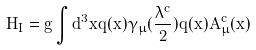Convert formula to latex. <formula><loc_0><loc_0><loc_500><loc_500>H _ { I } = g \int d ^ { 3 } x { \bar { q } } ( x ) \gamma _ { \mu } ( { \frac { \lambda ^ { c } } { 2 } } ) q ( x ) A _ { \mu } ^ { c } ( x )</formula> 